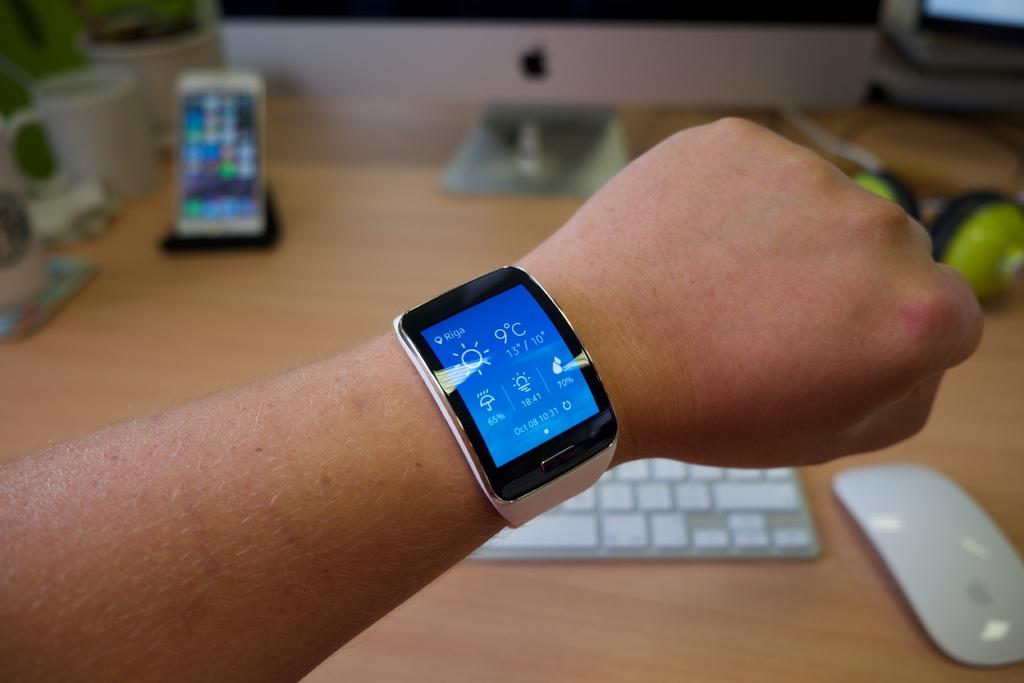<image>
Share a concise interpretation of the image provided. A person wearing a wristwatch which displays the temperature as 9 degrees. 